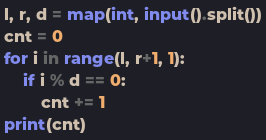<code> <loc_0><loc_0><loc_500><loc_500><_Python_>l, r, d = map(int, input().split())
cnt = 0
for i in range(l, r+1, 1):
    if i % d == 0:
        cnt += 1
print(cnt)</code> 